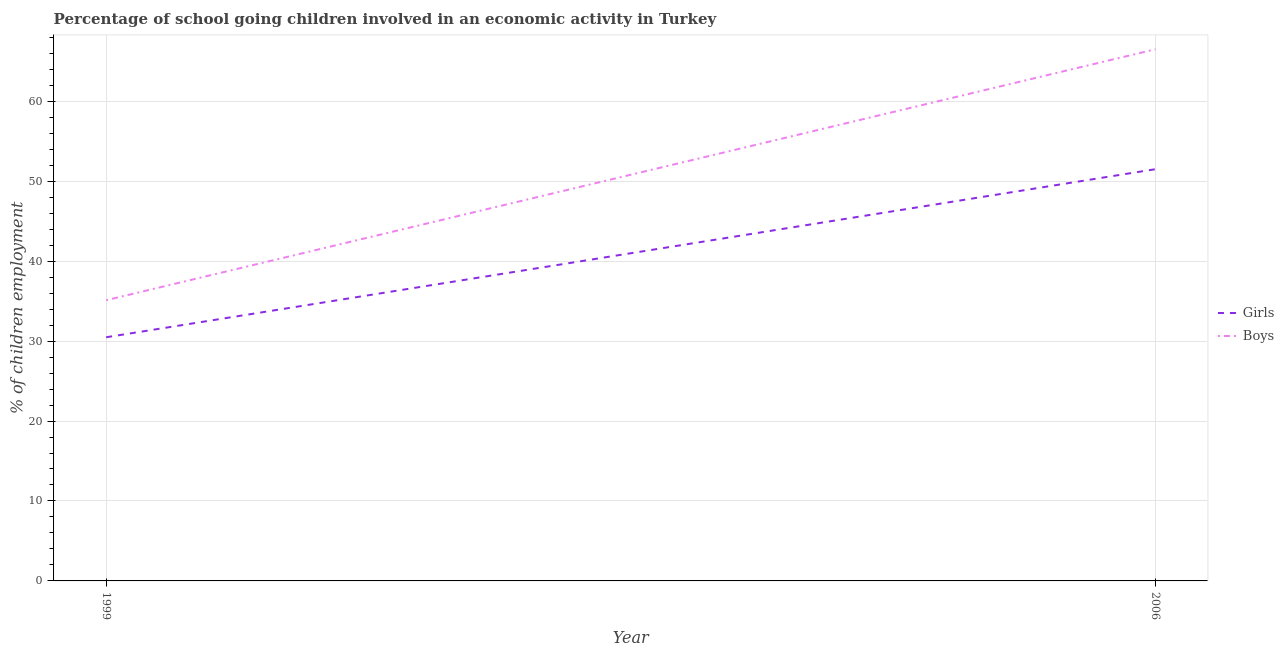Does the line corresponding to percentage of school going girls intersect with the line corresponding to percentage of school going boys?
Ensure brevity in your answer.  No. What is the percentage of school going girls in 2006?
Give a very brief answer. 51.5. Across all years, what is the maximum percentage of school going girls?
Your answer should be compact. 51.5. Across all years, what is the minimum percentage of school going boys?
Keep it short and to the point. 35.11. In which year was the percentage of school going boys maximum?
Give a very brief answer. 2006. In which year was the percentage of school going boys minimum?
Your answer should be very brief. 1999. What is the total percentage of school going girls in the graph?
Your answer should be compact. 81.98. What is the difference between the percentage of school going boys in 1999 and that in 2006?
Give a very brief answer. -31.39. What is the difference between the percentage of school going girls in 2006 and the percentage of school going boys in 1999?
Give a very brief answer. 16.39. What is the average percentage of school going girls per year?
Your answer should be compact. 40.99. In the year 1999, what is the difference between the percentage of school going girls and percentage of school going boys?
Offer a terse response. -4.64. What is the ratio of the percentage of school going boys in 1999 to that in 2006?
Provide a succinct answer. 0.53. Is the percentage of school going girls in 1999 less than that in 2006?
Offer a terse response. Yes. In how many years, is the percentage of school going boys greater than the average percentage of school going boys taken over all years?
Your answer should be compact. 1. Does the percentage of school going boys monotonically increase over the years?
Your answer should be very brief. Yes. Is the percentage of school going girls strictly less than the percentage of school going boys over the years?
Provide a short and direct response. Yes. How many lines are there?
Ensure brevity in your answer.  2. What is the difference between two consecutive major ticks on the Y-axis?
Make the answer very short. 10. Does the graph contain any zero values?
Offer a terse response. No. How are the legend labels stacked?
Give a very brief answer. Vertical. What is the title of the graph?
Ensure brevity in your answer.  Percentage of school going children involved in an economic activity in Turkey. Does "ODA received" appear as one of the legend labels in the graph?
Offer a terse response. No. What is the label or title of the X-axis?
Your answer should be compact. Year. What is the label or title of the Y-axis?
Offer a very short reply. % of children employment. What is the % of children employment of Girls in 1999?
Provide a succinct answer. 30.48. What is the % of children employment of Boys in 1999?
Ensure brevity in your answer.  35.11. What is the % of children employment of Girls in 2006?
Your response must be concise. 51.5. What is the % of children employment of Boys in 2006?
Offer a very short reply. 66.5. Across all years, what is the maximum % of children employment of Girls?
Make the answer very short. 51.5. Across all years, what is the maximum % of children employment of Boys?
Your response must be concise. 66.5. Across all years, what is the minimum % of children employment of Girls?
Your response must be concise. 30.48. Across all years, what is the minimum % of children employment in Boys?
Your answer should be compact. 35.11. What is the total % of children employment in Girls in the graph?
Provide a short and direct response. 81.98. What is the total % of children employment in Boys in the graph?
Your answer should be compact. 101.61. What is the difference between the % of children employment of Girls in 1999 and that in 2006?
Your response must be concise. -21.02. What is the difference between the % of children employment of Boys in 1999 and that in 2006?
Your answer should be very brief. -31.39. What is the difference between the % of children employment of Girls in 1999 and the % of children employment of Boys in 2006?
Provide a short and direct response. -36.02. What is the average % of children employment in Girls per year?
Your answer should be very brief. 40.99. What is the average % of children employment in Boys per year?
Your answer should be compact. 50.81. In the year 1999, what is the difference between the % of children employment in Girls and % of children employment in Boys?
Offer a very short reply. -4.64. In the year 2006, what is the difference between the % of children employment of Girls and % of children employment of Boys?
Provide a short and direct response. -15. What is the ratio of the % of children employment in Girls in 1999 to that in 2006?
Offer a terse response. 0.59. What is the ratio of the % of children employment of Boys in 1999 to that in 2006?
Your answer should be compact. 0.53. What is the difference between the highest and the second highest % of children employment in Girls?
Ensure brevity in your answer.  21.02. What is the difference between the highest and the second highest % of children employment of Boys?
Your answer should be very brief. 31.39. What is the difference between the highest and the lowest % of children employment of Girls?
Offer a very short reply. 21.02. What is the difference between the highest and the lowest % of children employment in Boys?
Keep it short and to the point. 31.39. 